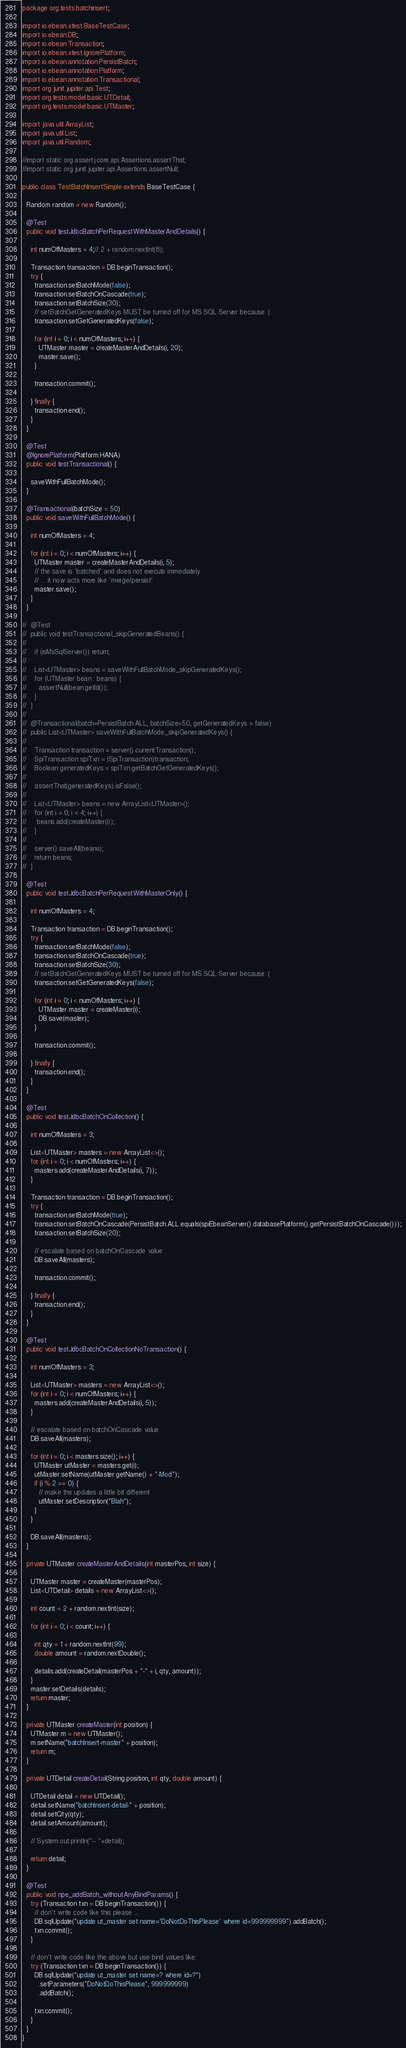<code> <loc_0><loc_0><loc_500><loc_500><_Java_>package org.tests.batchinsert;

import io.ebean.xtest.BaseTestCase;
import io.ebean.DB;
import io.ebean.Transaction;
import io.ebean.xtest.IgnorePlatform;
import io.ebean.annotation.PersistBatch;
import io.ebean.annotation.Platform;
import io.ebean.annotation.Transactional;
import org.junit.jupiter.api.Test;
import org.tests.model.basic.UTDetail;
import org.tests.model.basic.UTMaster;

import java.util.ArrayList;
import java.util.List;
import java.util.Random;

//import static org.assertj.core.api.Assertions.assertThat;
//import static org.junit.jupiter.api.Assertions.assertNull;

public class TestBatchInsertSimple extends BaseTestCase {

  Random random = new Random();

  @Test
  public void testJdbcBatchPerRequestWithMasterAndDetails() {

    int numOfMasters = 4;// 2 + random.nextInt(8);

    Transaction transaction = DB.beginTransaction();
    try {
      transaction.setBatchMode(false);
      transaction.setBatchOnCascade(true);
      transaction.setBatchSize(30);
      // setBatchGetGeneratedKeys MUST be turned off for MS SQL Server because :(
      transaction.setGetGeneratedKeys(false);

      for (int i = 0; i < numOfMasters; i++) {
        UTMaster master = createMasterAndDetails(i, 20);
        master.save();
      }

      transaction.commit();

    } finally {
      transaction.end();
    }
  }

  @Test
  @IgnorePlatform(Platform.HANA)
  public void testTransactional() {

    saveWithFullBatchMode();
  }

  @Transactional(batchSize = 50)
  public void saveWithFullBatchMode() {

    int numOfMasters = 4;

    for (int i = 0; i < numOfMasters; i++) {
      UTMaster master = createMasterAndDetails(i, 5);
      // the save is 'batched' and does not execute immediately
      // ... it now acts more like 'merge/persist'
      master.save();
    }
  }

//  @Test
//  public void testTransactional_skipGeneratedBeans() {
//
//    if (isMsSqlServer()) return;
//
//    List<UTMaster> beans = saveWithFullBatchMode_skipGeneratedKeys();
//    for (UTMaster bean : beans) {
//      assertNull(bean.getId());
//    }
//  }
//
//  @Transactional(batch=PersistBatch.ALL, batchSize=50, getGeneratedKeys = false)
//  public List<UTMaster> saveWithFullBatchMode_skipGeneratedKeys() {
//
//    Transaction transaction = server().currentTransaction();
//    SpiTransaction spiTxn = (SpiTransaction)transaction;
//    Boolean generatedKeys = spiTxn.getBatchGetGeneratedKeys();
//
//    assertThat(generatedKeys).isFalse();
//
//    List<UTMaster> beans = new ArrayList<UTMaster>();
//    for (int i = 0; i < 4; i++) {
//     beans.add(createMaster(i));
//    }
//
//    server().saveAll(beans);
//    return beans;
//  }

  @Test
  public void testJdbcBatchPerRequestWithMasterOnly() {

    int numOfMasters = 4;

    Transaction transaction = DB.beginTransaction();
    try {
      transaction.setBatchMode(false);
      transaction.setBatchOnCascade(true);
      transaction.setBatchSize(30);
      // setBatchGetGeneratedKeys MUST be turned off for MS SQL Server because :(
      transaction.setGetGeneratedKeys(false);

      for (int i = 0; i < numOfMasters; i++) {
        UTMaster master = createMaster(i);
        DB.save(master);
      }

      transaction.commit();

    } finally {
      transaction.end();
    }
  }

  @Test
  public void testJdbcBatchOnCollection() {

    int numOfMasters = 3;

    List<UTMaster> masters = new ArrayList<>();
    for (int i = 0; i < numOfMasters; i++) {
      masters.add(createMasterAndDetails(i, 7));
    }

    Transaction transaction = DB.beginTransaction();
    try {
      transaction.setBatchMode(true);
      transaction.setBatchOnCascade(PersistBatch.ALL.equals(spiEbeanServer().databasePlatform().getPersistBatchOnCascade()));
      transaction.setBatchSize(20);

      // escalate based on batchOnCascade value
      DB.saveAll(masters);

      transaction.commit();

    } finally {
      transaction.end();
    }
  }

  @Test
  public void testJdbcBatchOnCollectionNoTransaction() {

    int numOfMasters = 3;

    List<UTMaster> masters = new ArrayList<>();
    for (int i = 0; i < numOfMasters; i++) {
      masters.add(createMasterAndDetails(i, 5));
    }

    // escalate based on batchOnCascade value
    DB.saveAll(masters);

    for (int i = 0; i < masters.size(); i++) {
      UTMaster utMaster = masters.get(i);
      utMaster.setName(utMaster.getName() + "-Mod");
      if (i % 2 == 0) {
        // make the updates a little bit different
        utMaster.setDescription("Blah");
      }
    }

    DB.saveAll(masters);
  }

  private UTMaster createMasterAndDetails(int masterPos, int size) {

    UTMaster master = createMaster(masterPos);
    List<UTDetail> details = new ArrayList<>();

    int count = 2 + random.nextInt(size);

    for (int i = 0; i < count; i++) {

      int qty = 1 + random.nextInt(99);
      double amount = random.nextDouble();

      details.add(createDetail(masterPos + "-" + i, qty, amount));
    }
    master.setDetails(details);
    return master;
  }

  private UTMaster createMaster(int position) {
    UTMaster m = new UTMaster();
    m.setName("batchInsert-master" + position);
    return m;
  }

  private UTDetail createDetail(String position, int qty, double amount) {

    UTDetail detail = new UTDetail();
    detail.setName("batchInsert-detail-" + position);
    detail.setQty(qty);
    detail.setAmount(amount);

    // System.out.println("-- "+detail);

    return detail;
  }

  @Test
  public void npe_addBatch_withoutAnyBindParams() {
    try (Transaction txn = DB.beginTransaction()) {
      // don't write code like this please ...
      DB.sqlUpdate("update ut_master set name='DoNotDoThisPlease' where id=999999999").addBatch();
      txn.commit();
    }

    // don't write code like the above but use bind values like:
    try (Transaction txn = DB.beginTransaction()) {
      DB.sqlUpdate("update ut_master set name=? where id=?")
        .setParameters("DoNotDoThisPlease", 999999999)
        .addBatch();

      txn.commit();
    }
  }
}
</code> 